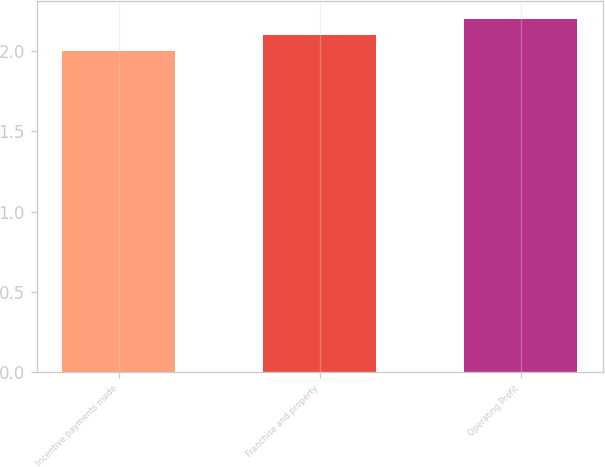<chart> <loc_0><loc_0><loc_500><loc_500><bar_chart><fcel>Incentive payments made<fcel>Franchise and property<fcel>Operating Profit<nl><fcel>2<fcel>2.1<fcel>2.2<nl></chart> 